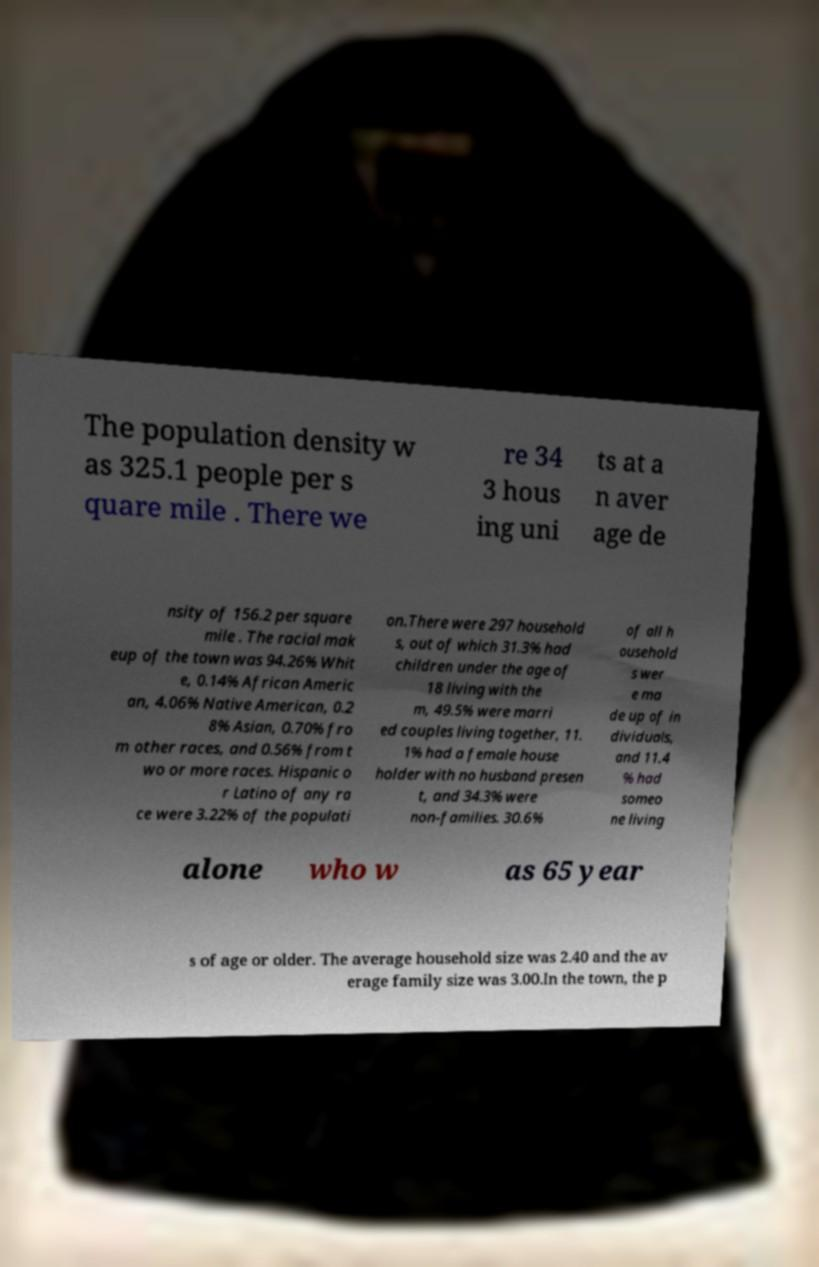Can you read and provide the text displayed in the image?This photo seems to have some interesting text. Can you extract and type it out for me? The population density w as 325.1 people per s quare mile . There we re 34 3 hous ing uni ts at a n aver age de nsity of 156.2 per square mile . The racial mak eup of the town was 94.26% Whit e, 0.14% African Americ an, 4.06% Native American, 0.2 8% Asian, 0.70% fro m other races, and 0.56% from t wo or more races. Hispanic o r Latino of any ra ce were 3.22% of the populati on.There were 297 household s, out of which 31.3% had children under the age of 18 living with the m, 49.5% were marri ed couples living together, 11. 1% had a female house holder with no husband presen t, and 34.3% were non-families. 30.6% of all h ousehold s wer e ma de up of in dividuals, and 11.4 % had someo ne living alone who w as 65 year s of age or older. The average household size was 2.40 and the av erage family size was 3.00.In the town, the p 